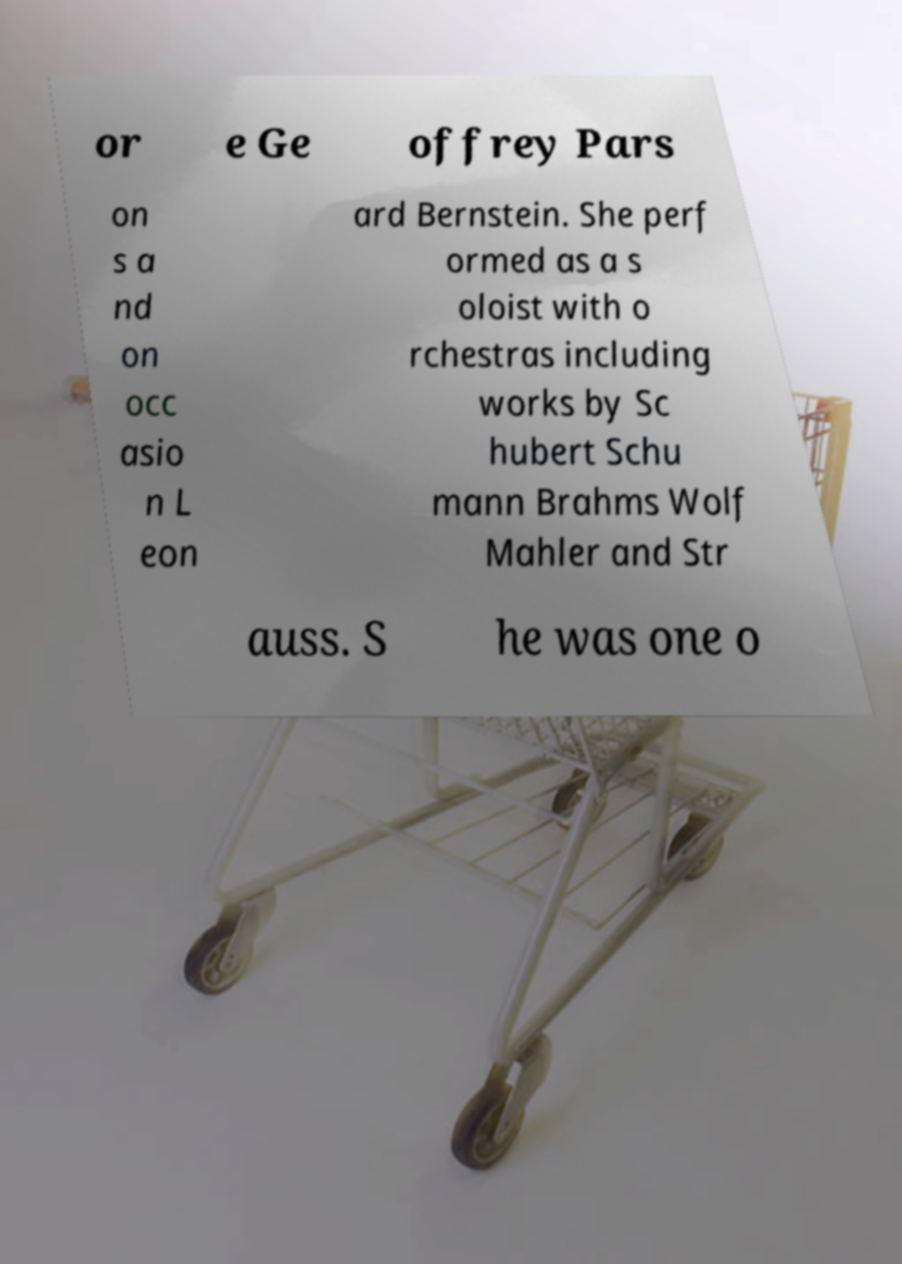What messages or text are displayed in this image? I need them in a readable, typed format. or e Ge offrey Pars on s a nd on occ asio n L eon ard Bernstein. She perf ormed as a s oloist with o rchestras including works by Sc hubert Schu mann Brahms Wolf Mahler and Str auss. S he was one o 